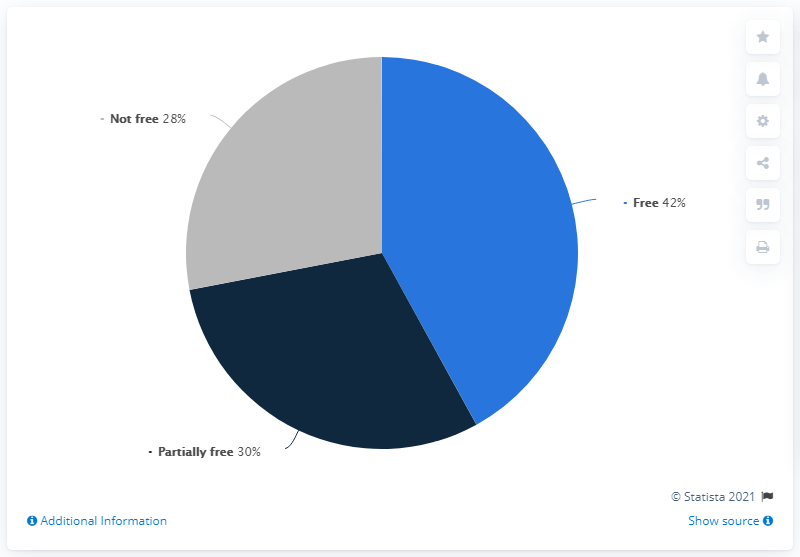List a handful of essential elements in this visual. In total, 72 people are free or partially free. 